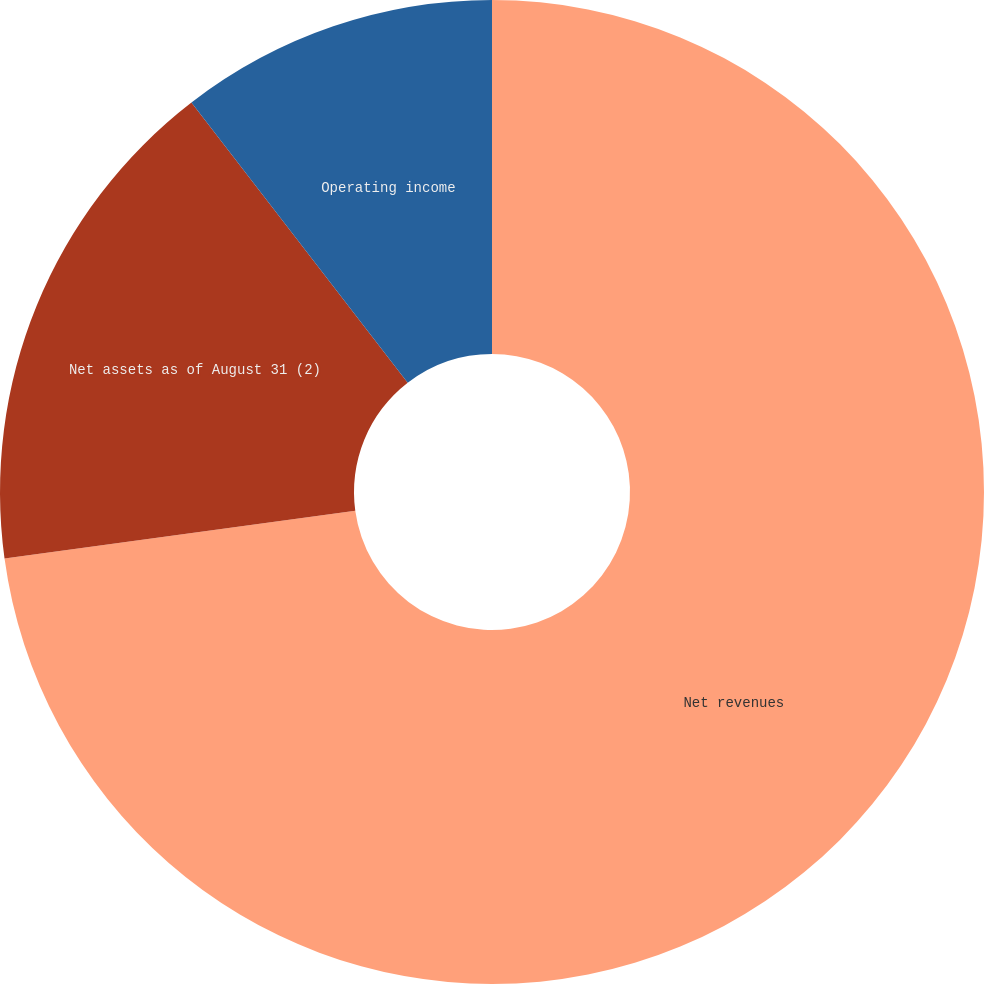Convert chart to OTSL. <chart><loc_0><loc_0><loc_500><loc_500><pie_chart><fcel>Net revenues<fcel>Net assets as of August 31 (2)<fcel>Operating income<nl><fcel>72.84%<fcel>16.7%<fcel>10.46%<nl></chart> 